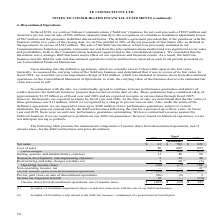According to Te Connectivity's financial document, What did the amount of Restructuring and other charges (credits), net in 2018 include? $19 million impairment charge recorded in connection with the sale of our SubCom business. The document states: "(1) Included a $19 million impairment charge recorded in connection with the sale of our SubCom business...." Also, What did the amount of Non-operating income, net in 2017 include? $19 million credit related to the SubCom business’ curtailment of a postretirement benefit plan.. The document states: "(2) Included a $19 million credit related to the SubCom business’ curtailment of a postretirement benefit plan...." Also, For which years were the components of income (loss) from discontinued operations, net of income taxes, for the SubCom business and prior divestitures provided? The document contains multiple relevant values: 2019, 2018, 2017. From the document: "2019 2018 2017 2019 2018 2017 2019 2018 2017..." Additionally, In which year was the amount of Cost of sales largest? According to the financial document, 2017. The relevant text states: "2019 2018 2017..." Also, can you calculate: What was the change in Selling, general, and administrative expenses in 2019 from 2018? Based on the calculation: 11-48, the result is -37 (in millions). This is based on the information: "Selling, general, and administrative expenses 11 48 50 Selling, general, and administrative expenses 11 48 50..." The key data points involved are: 11, 48. Also, can you calculate: What was the percentage change in Selling, general, and administrative expenses in 2019 from 2018? To answer this question, I need to perform calculations using the financial data. The calculation is: (11-48)/48, which equals -77.08 (percentage). This is based on the information: "Selling, general, and administrative expenses 11 48 50 Selling, general, and administrative expenses 11 48 50..." The key data points involved are: 11, 48. 